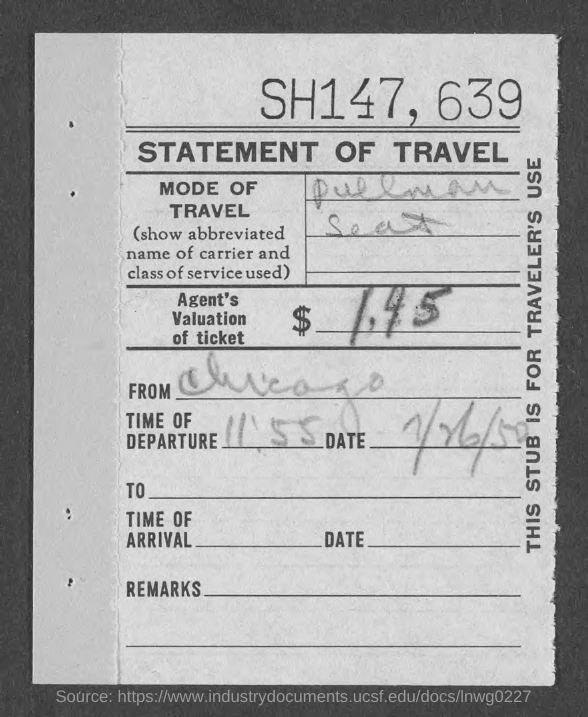What is the Title of the document?
Provide a short and direct response. STATEMENT OF TRAVEL. What is the mode of travel?
Provide a succinct answer. Pullman Seat. What is the Agent's valuation of ticket?
Provide a succinct answer. $1.45. Where is it From?
Your answer should be very brief. Chicago. What is the time of departure?
Your response must be concise. 11'55. 